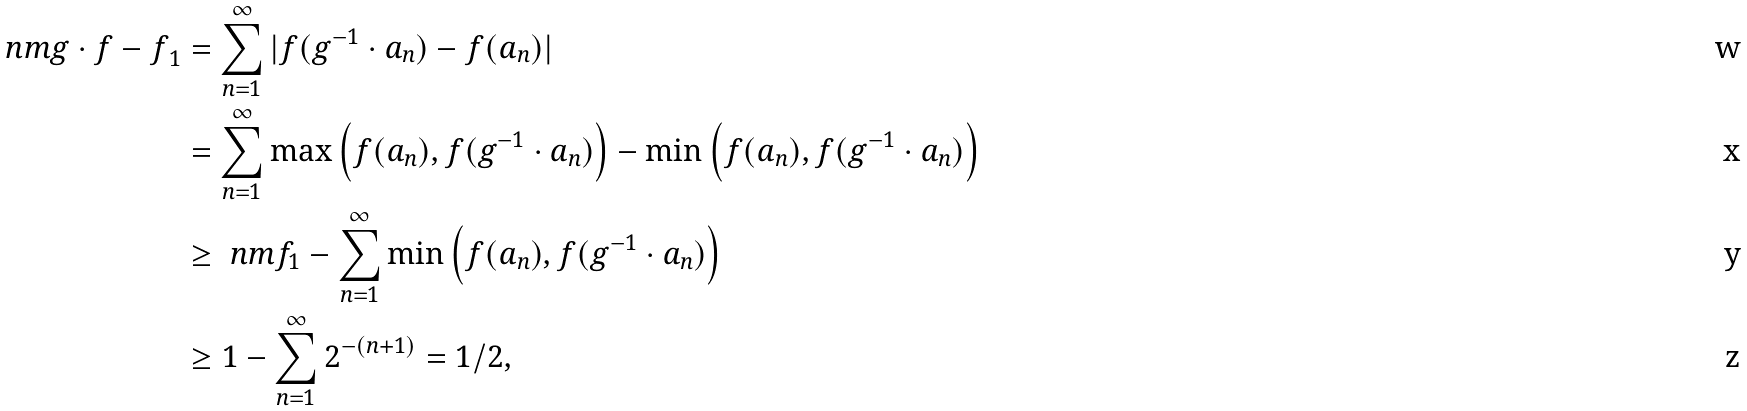<formula> <loc_0><loc_0><loc_500><loc_500>\ n m { g \cdot f - f } _ { 1 } & = \sum _ { n = 1 } ^ { \infty } | f ( g ^ { - 1 } \cdot a _ { n } ) - f ( a _ { n } ) | \\ & = \sum _ { n = 1 } ^ { \infty } \max \left ( f ( a _ { n } ) , f ( g ^ { - 1 } \cdot a _ { n } ) \right ) - \min \left ( f ( a _ { n } ) , f ( g ^ { - 1 } \cdot a _ { n } ) \right ) \\ & \geq \ n m { f } _ { 1 } - \sum _ { n = 1 } ^ { \infty } \min \left ( f ( a _ { n } ) , f ( g ^ { - 1 } \cdot a _ { n } ) \right ) \\ & \geq 1 - \sum _ { n = 1 } ^ { \infty } 2 ^ { - ( n + 1 ) } = 1 / 2 ,</formula> 